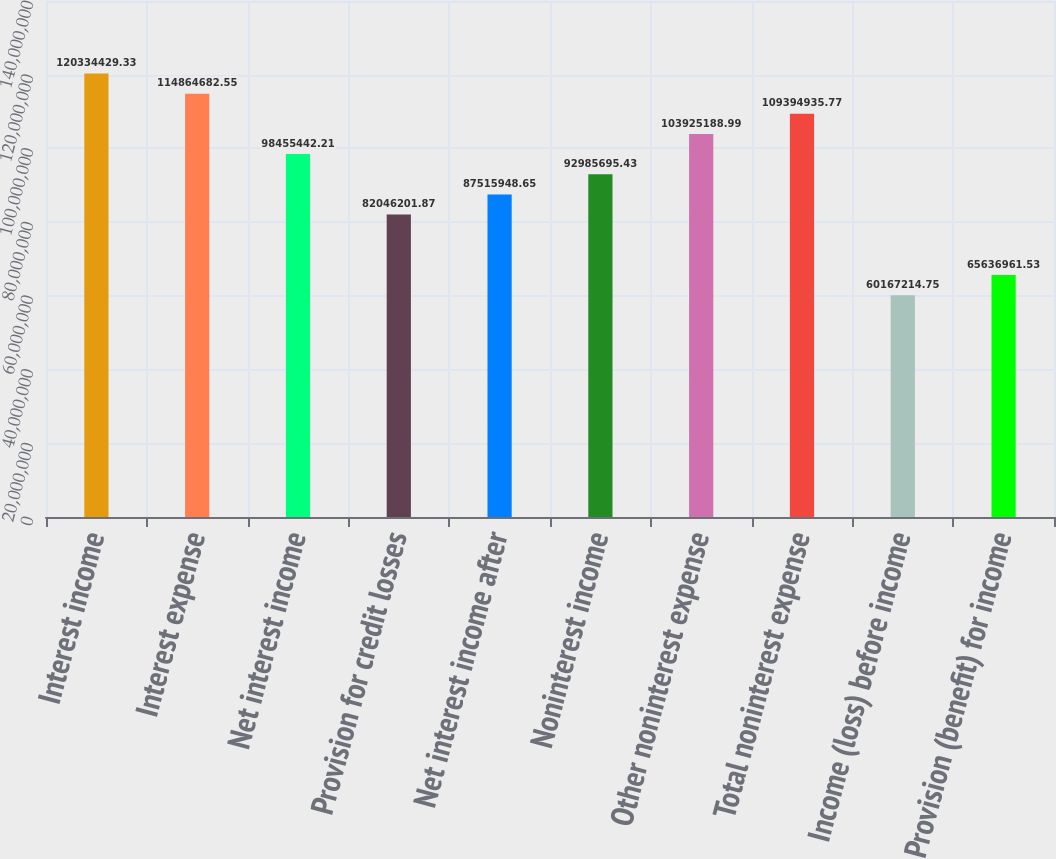<chart> <loc_0><loc_0><loc_500><loc_500><bar_chart><fcel>Interest income<fcel>Interest expense<fcel>Net interest income<fcel>Provision for credit losses<fcel>Net interest income after<fcel>Noninterest income<fcel>Other noninterest expense<fcel>Total noninterest expense<fcel>Income (loss) before income<fcel>Provision (benefit) for income<nl><fcel>1.20334e+08<fcel>1.14865e+08<fcel>9.84554e+07<fcel>8.20462e+07<fcel>8.75159e+07<fcel>9.29857e+07<fcel>1.03925e+08<fcel>1.09395e+08<fcel>6.01672e+07<fcel>6.5637e+07<nl></chart> 